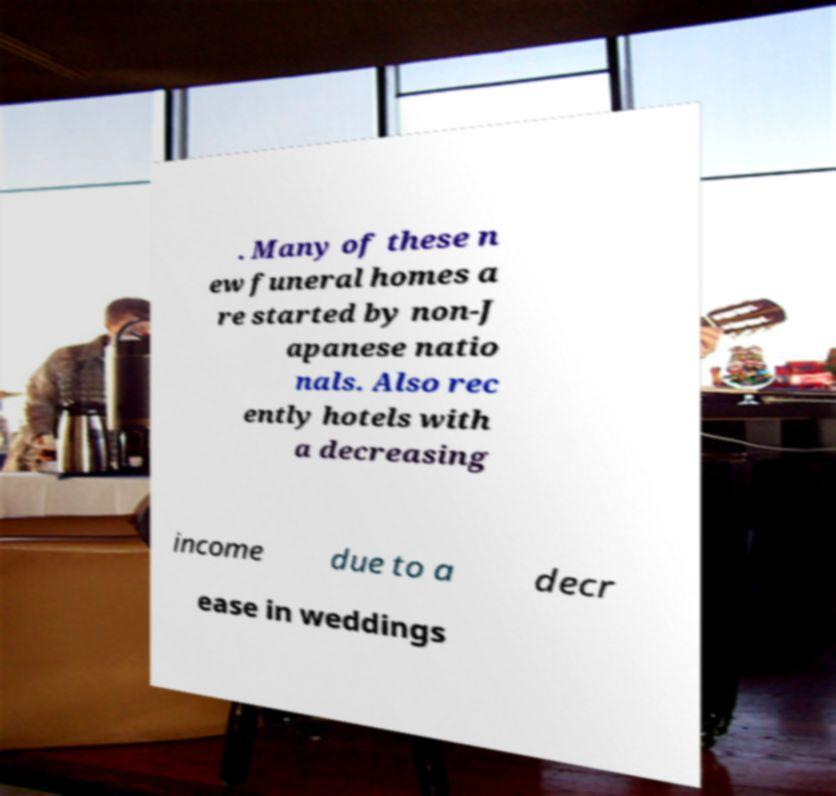Please identify and transcribe the text found in this image. . Many of these n ew funeral homes a re started by non-J apanese natio nals. Also rec ently hotels with a decreasing income due to a decr ease in weddings 